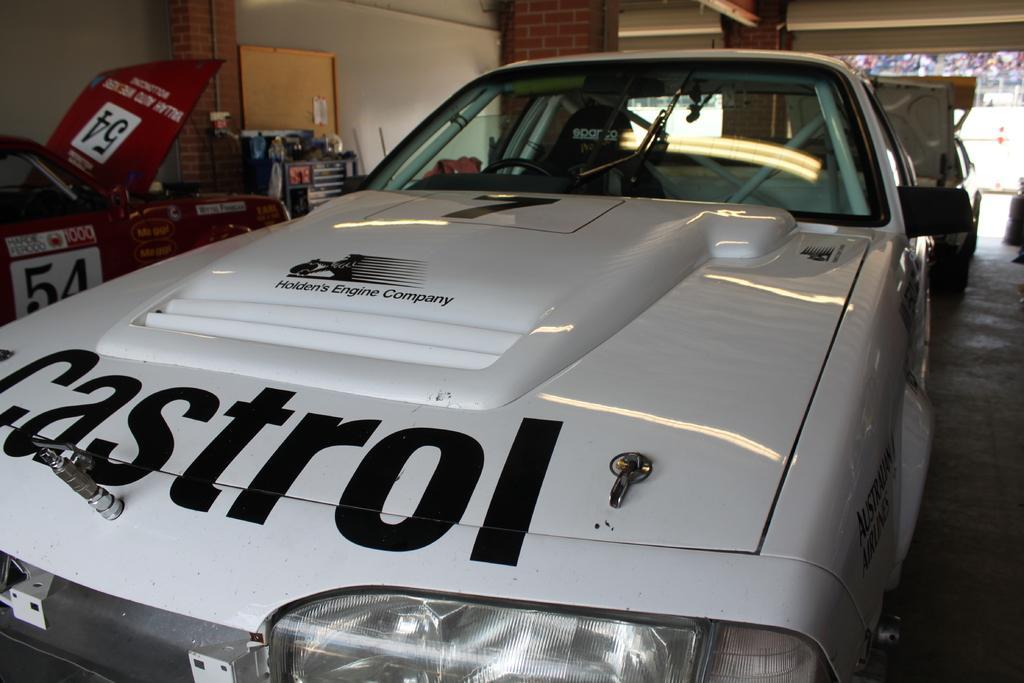How would you summarize this image in a sentence or two? In this image we can see racing cars. On the left there is a stand. In the background there is a wall. 